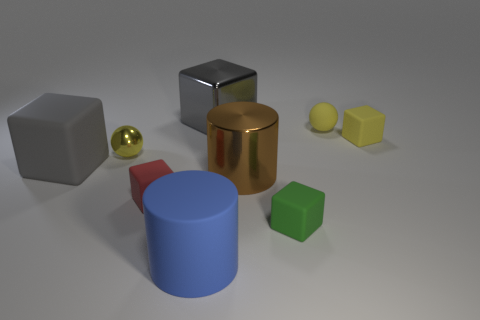What time of day or lighting conditions does the scene seem to represent? The lighting in the scene suggests an interior space with artificial lighting. The soft shadows and diffuse light on the objects imply a source of light that is not overly harsh or direct, such as what one might experience indoors with ambient lighting or soft studio lights designed to minimize harsh shadows. 